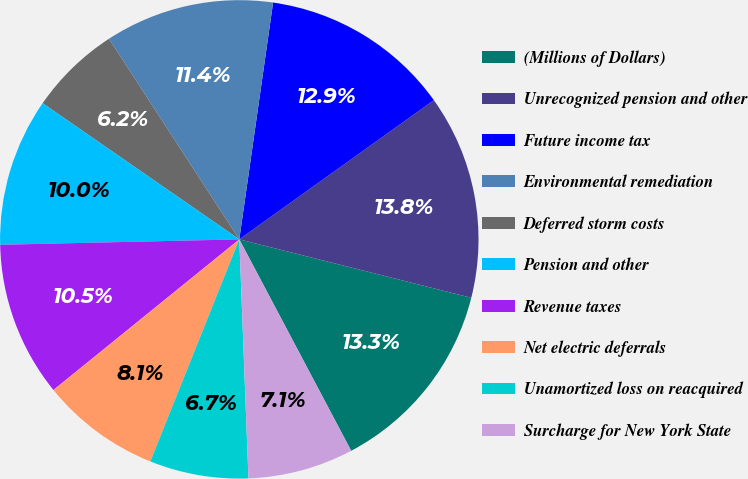<chart> <loc_0><loc_0><loc_500><loc_500><pie_chart><fcel>(Millions of Dollars)<fcel>Unrecognized pension and other<fcel>Future income tax<fcel>Environmental remediation<fcel>Deferred storm costs<fcel>Pension and other<fcel>Revenue taxes<fcel>Net electric deferrals<fcel>Unamortized loss on reacquired<fcel>Surcharge for New York State<nl><fcel>13.33%<fcel>13.81%<fcel>12.86%<fcel>11.43%<fcel>6.19%<fcel>10.0%<fcel>10.48%<fcel>8.1%<fcel>6.67%<fcel>7.14%<nl></chart> 